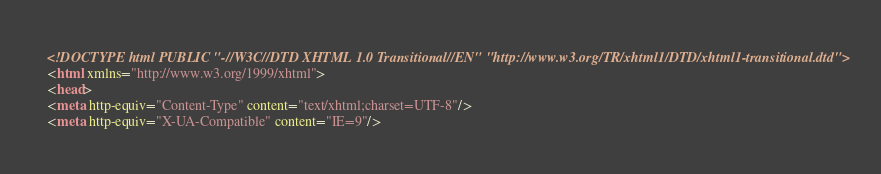<code> <loc_0><loc_0><loc_500><loc_500><_HTML_><!DOCTYPE html PUBLIC "-//W3C//DTD XHTML 1.0 Transitional//EN" "http://www.w3.org/TR/xhtml1/DTD/xhtml1-transitional.dtd">
<html xmlns="http://www.w3.org/1999/xhtml">
<head>
<meta http-equiv="Content-Type" content="text/xhtml;charset=UTF-8"/>
<meta http-equiv="X-UA-Compatible" content="IE=9"/></code> 